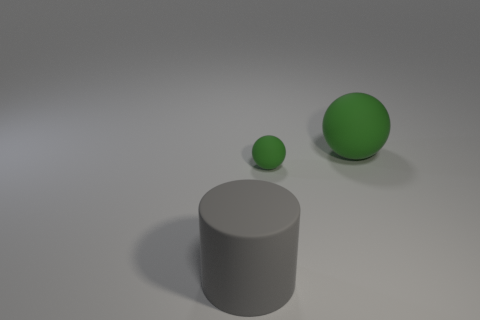What is the shape of the green object behind the green matte thing that is in front of the large rubber thing that is to the right of the big matte cylinder?
Provide a short and direct response. Sphere. Does the large matte object that is behind the large gray rubber cylinder have the same shape as the green rubber thing on the left side of the large rubber sphere?
Provide a succinct answer. Yes. How many cylinders are either big green matte objects or matte things?
Give a very brief answer. 1. Are the large green ball and the gray cylinder made of the same material?
Make the answer very short. Yes. How many other objects are there of the same color as the tiny matte sphere?
Your answer should be compact. 1. There is a big thing in front of the large matte sphere; what shape is it?
Offer a very short reply. Cylinder. What number of things are large green spheres or tiny rubber objects?
Offer a terse response. 2. Do the cylinder and the thing to the right of the tiny sphere have the same size?
Offer a terse response. Yes. How many other things are there of the same material as the tiny sphere?
Give a very brief answer. 2. What number of things are large matte things to the right of the gray cylinder or balls that are behind the small matte sphere?
Keep it short and to the point. 1. 